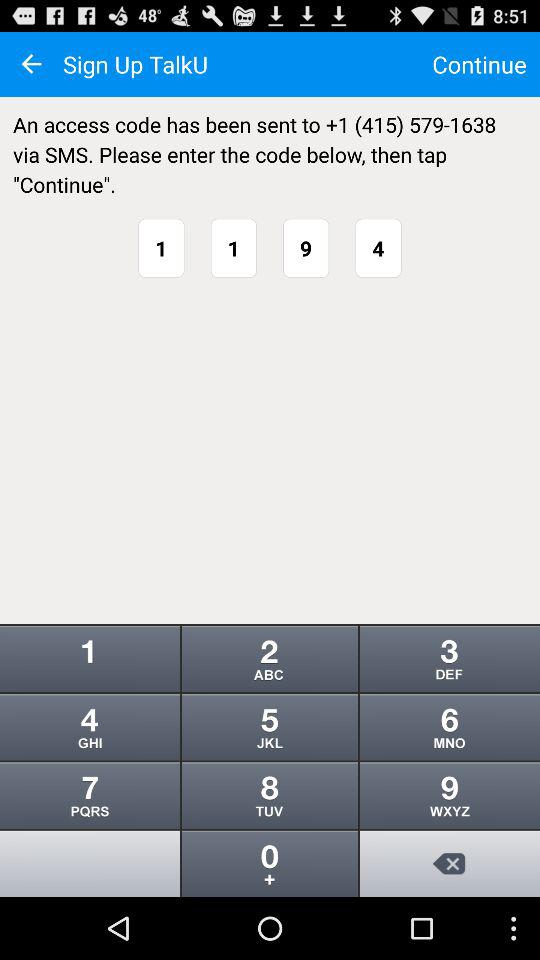What is the contact number? The contact number is +1 (415) 579-1638. 